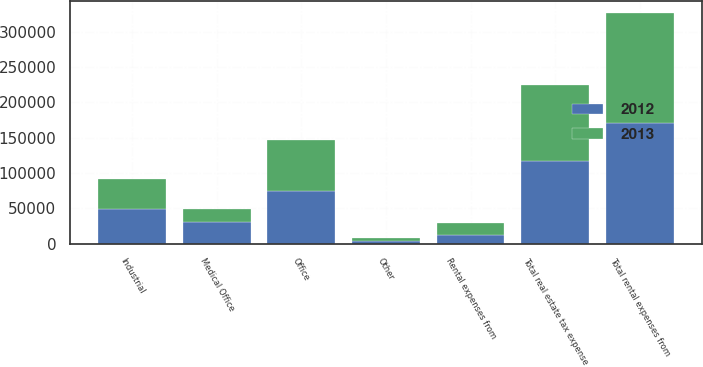Convert chart to OTSL. <chart><loc_0><loc_0><loc_500><loc_500><stacked_bar_chart><ecel><fcel>Industrial<fcel>Office<fcel>Medical Office<fcel>Other<fcel>Total rental expenses from<fcel>Rental expenses from<fcel>Total real estate tax expense<nl><fcel>2012<fcel>49165<fcel>75008<fcel>30455<fcel>4380<fcel>171057<fcel>12049<fcel>117747<nl><fcel>2013<fcel>42830<fcel>71910<fcel>19386<fcel>3671<fcel>155390<fcel>17593<fcel>106128<nl></chart> 